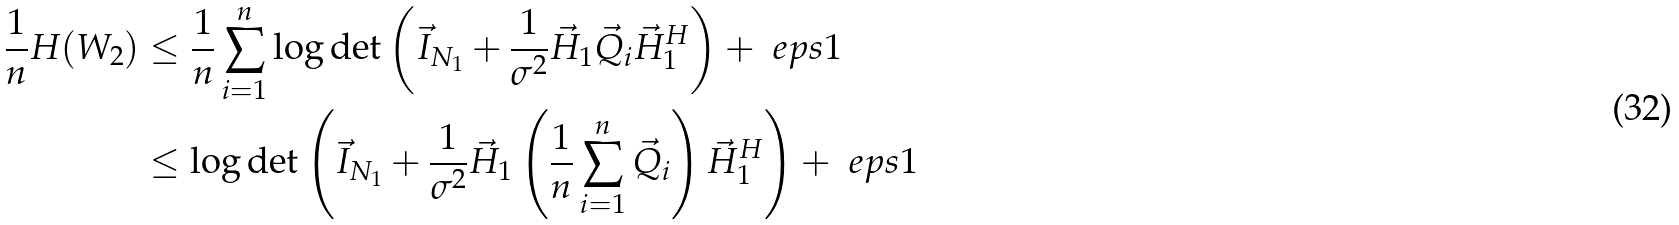Convert formula to latex. <formula><loc_0><loc_0><loc_500><loc_500>\frac { 1 } { n } H ( W _ { 2 } ) & \leq \frac { 1 } { n } \sum _ { i = 1 } ^ { n } { \log \det \left ( \vec { I } _ { N _ { 1 } } + \frac { 1 } { \sigma ^ { 2 } } \vec { H } _ { 1 } \vec { Q } _ { i } \vec { H } _ { 1 } ^ { H } \right ) } + \ e p s { 1 } \\ & \leq \log \det \left ( \vec { I } _ { N _ { 1 } } + \frac { 1 } { \sigma ^ { 2 } } \vec { H } _ { 1 } \left ( \frac { 1 } { n } \sum _ { i = 1 } ^ { n } { \vec { Q } _ { i } } \right ) \vec { H } _ { 1 } ^ { H } \right ) + \ e p s { 1 }</formula> 